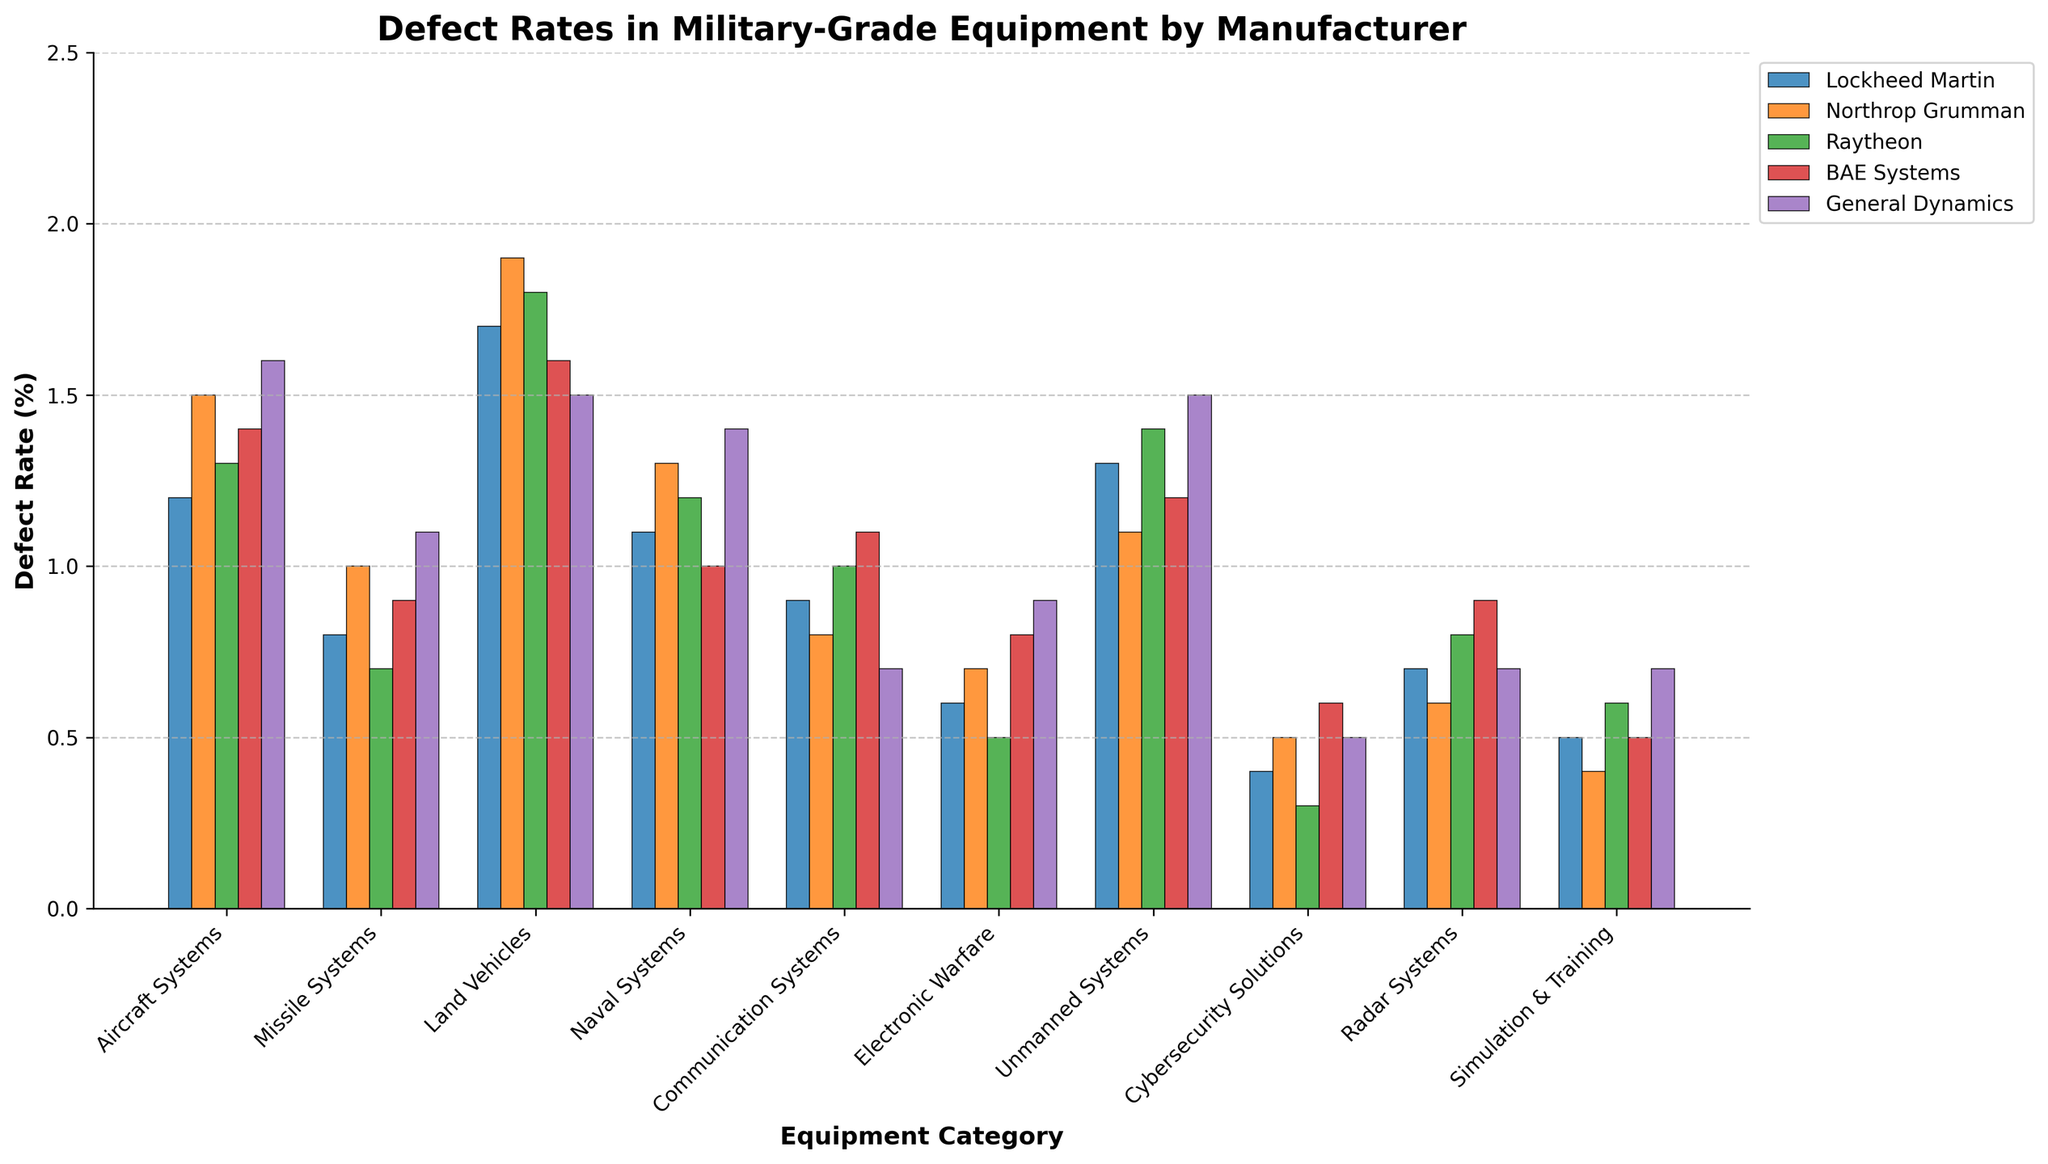Which manufacturer has the highest defect rate in Aircraft Systems? By examining the height of the bars in the Aircraft Systems category, the bar representing General Dynamics is the tallest.
Answer: General Dynamics Compare the defect rates for Land Vehicles between Lockheed Martin and Northrop Grumman. Which one is higher? The Land Vehicles category shows that Northrop Grumman's bar is slightly taller than Lockheed Martin's bar.
Answer: Northrop Grumman What's the difference in defect rates between the highest and lowest defect rates in the Communication Systems category? The highest defect rate in Communication Systems is for BAE Systems (1.1%) and the lowest for General Dynamics (0.7%). The difference is 1.1 - 0.7 = 0.4.
Answer: 0.4 Which equipment category has the lowest overall defect rates across all manufacturers? By observing the shortest bars across all manufacturers for each category, Cybersecurity Solutions has the lowest rates overall.
Answer: Cybersecurity Solutions What is the average defect rate for Missile Systems across all manufacturers? Add all defect rates for Missile Systems (0.8 + 1.0 + 0.7 + 0.9 + 1.1 = 4.5) and divide by the number of manufacturers (5). Average = 4.5 / 5 = 0.9
Answer: 0.9 Is Northrop Grumman's defect rate for Radar Systems greater than Raytheon's? For the Radar Systems category, Northrop Grumman’s bar is shorter than Raytheon’s bar.
Answer: No Which manufacturer has the most consistent defect rates across all equipment categories? By looking for the manufacturer with bars of similar height across all categories, Northrop Grumman and Raytheon appear the most consistent, but Northrop Grumman has slightly more balanced heights.
Answer: Northrop Grumman How does General Dynamics' defect rate in Electronic Warfare compare to Lockheed Martin's? The bars for General Dynamics and Lockheed Martin in the Electronic Warfare category show General Dynamics has a taller bar compared to Lockheed Martin.
Answer: Higher Identify the Equipment Category where Raytheon has the highest defect rate. Scan Raytheon’s bars across all categories; the highest one is in Unmanned Systems.
Answer: Unmanned Systems Which equipment category shows the greatest variability in defect rates among the manufacturers? By comparing the range of bar heights across all categories, Land Vehicles show the highest variability.
Answer: Land Vehicles 